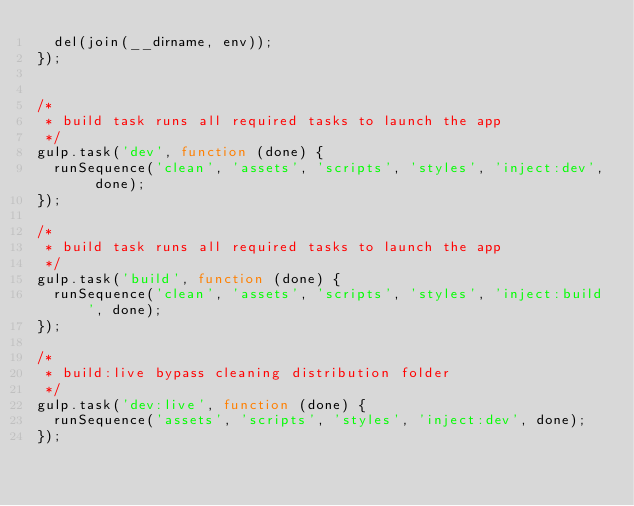Convert code to text. <code><loc_0><loc_0><loc_500><loc_500><_JavaScript_>  del(join(__dirname, env));
});


/*
 * build task runs all required tasks to launch the app
 */
gulp.task('dev', function (done) {
  runSequence('clean', 'assets', 'scripts', 'styles', 'inject:dev', done);
});

/*
 * build task runs all required tasks to launch the app
 */
gulp.task('build', function (done) {
  runSequence('clean', 'assets', 'scripts', 'styles', 'inject:build', done);
});

/*
 * build:live bypass cleaning distribution folder
 */
gulp.task('dev:live', function (done) {
  runSequence('assets', 'scripts', 'styles', 'inject:dev', done);
});
</code> 